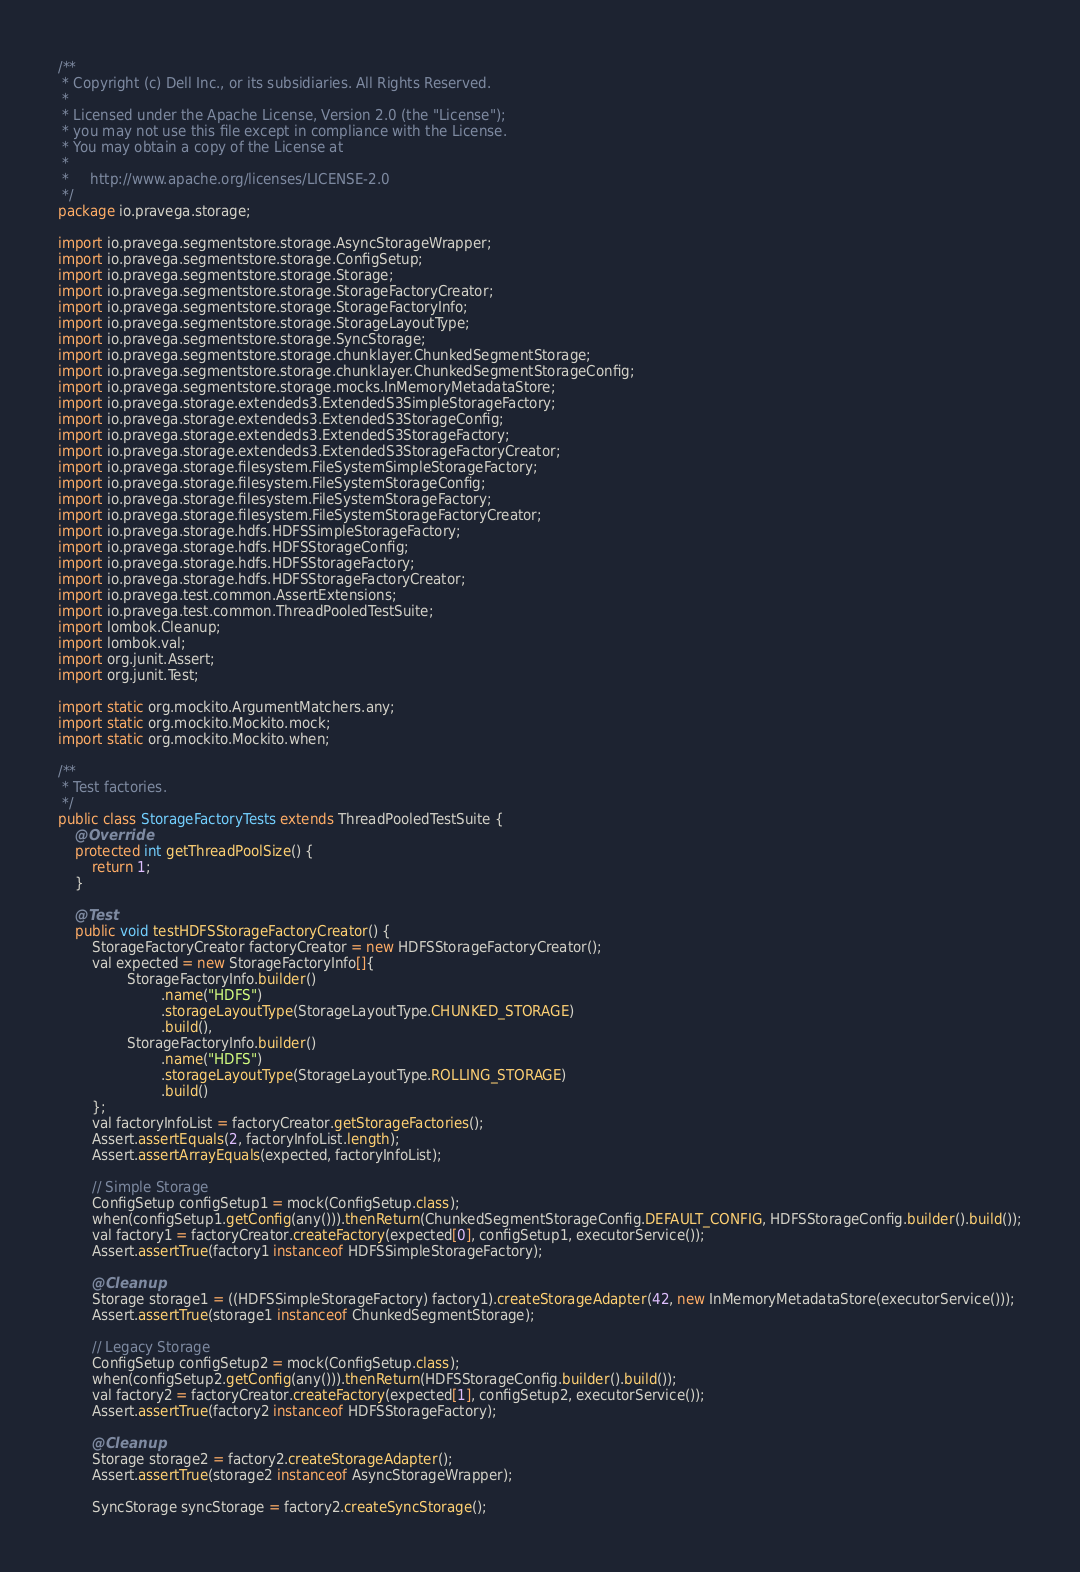Convert code to text. <code><loc_0><loc_0><loc_500><loc_500><_Java_>/**
 * Copyright (c) Dell Inc., or its subsidiaries. All Rights Reserved.
 *
 * Licensed under the Apache License, Version 2.0 (the "License");
 * you may not use this file except in compliance with the License.
 * You may obtain a copy of the License at
 *
 *     http://www.apache.org/licenses/LICENSE-2.0
 */
package io.pravega.storage;

import io.pravega.segmentstore.storage.AsyncStorageWrapper;
import io.pravega.segmentstore.storage.ConfigSetup;
import io.pravega.segmentstore.storage.Storage;
import io.pravega.segmentstore.storage.StorageFactoryCreator;
import io.pravega.segmentstore.storage.StorageFactoryInfo;
import io.pravega.segmentstore.storage.StorageLayoutType;
import io.pravega.segmentstore.storage.SyncStorage;
import io.pravega.segmentstore.storage.chunklayer.ChunkedSegmentStorage;
import io.pravega.segmentstore.storage.chunklayer.ChunkedSegmentStorageConfig;
import io.pravega.segmentstore.storage.mocks.InMemoryMetadataStore;
import io.pravega.storage.extendeds3.ExtendedS3SimpleStorageFactory;
import io.pravega.storage.extendeds3.ExtendedS3StorageConfig;
import io.pravega.storage.extendeds3.ExtendedS3StorageFactory;
import io.pravega.storage.extendeds3.ExtendedS3StorageFactoryCreator;
import io.pravega.storage.filesystem.FileSystemSimpleStorageFactory;
import io.pravega.storage.filesystem.FileSystemStorageConfig;
import io.pravega.storage.filesystem.FileSystemStorageFactory;
import io.pravega.storage.filesystem.FileSystemStorageFactoryCreator;
import io.pravega.storage.hdfs.HDFSSimpleStorageFactory;
import io.pravega.storage.hdfs.HDFSStorageConfig;
import io.pravega.storage.hdfs.HDFSStorageFactory;
import io.pravega.storage.hdfs.HDFSStorageFactoryCreator;
import io.pravega.test.common.AssertExtensions;
import io.pravega.test.common.ThreadPooledTestSuite;
import lombok.Cleanup;
import lombok.val;
import org.junit.Assert;
import org.junit.Test;

import static org.mockito.ArgumentMatchers.any;
import static org.mockito.Mockito.mock;
import static org.mockito.Mockito.when;

/**
 * Test factories.
 */
public class StorageFactoryTests extends ThreadPooledTestSuite {
    @Override
    protected int getThreadPoolSize() {
        return 1;
    }

    @Test
    public void testHDFSStorageFactoryCreator() {
        StorageFactoryCreator factoryCreator = new HDFSStorageFactoryCreator();
        val expected = new StorageFactoryInfo[]{
                StorageFactoryInfo.builder()
                        .name("HDFS")
                        .storageLayoutType(StorageLayoutType.CHUNKED_STORAGE)
                        .build(),
                StorageFactoryInfo.builder()
                        .name("HDFS")
                        .storageLayoutType(StorageLayoutType.ROLLING_STORAGE)
                        .build()
        };
        val factoryInfoList = factoryCreator.getStorageFactories();
        Assert.assertEquals(2, factoryInfoList.length);
        Assert.assertArrayEquals(expected, factoryInfoList);

        // Simple Storage
        ConfigSetup configSetup1 = mock(ConfigSetup.class);
        when(configSetup1.getConfig(any())).thenReturn(ChunkedSegmentStorageConfig.DEFAULT_CONFIG, HDFSStorageConfig.builder().build());
        val factory1 = factoryCreator.createFactory(expected[0], configSetup1, executorService());
        Assert.assertTrue(factory1 instanceof HDFSSimpleStorageFactory);

        @Cleanup
        Storage storage1 = ((HDFSSimpleStorageFactory) factory1).createStorageAdapter(42, new InMemoryMetadataStore(executorService()));
        Assert.assertTrue(storage1 instanceof ChunkedSegmentStorage);

        // Legacy Storage
        ConfigSetup configSetup2 = mock(ConfigSetup.class);
        when(configSetup2.getConfig(any())).thenReturn(HDFSStorageConfig.builder().build());
        val factory2 = factoryCreator.createFactory(expected[1], configSetup2, executorService());
        Assert.assertTrue(factory2 instanceof HDFSStorageFactory);

        @Cleanup
        Storage storage2 = factory2.createStorageAdapter();
        Assert.assertTrue(storage2 instanceof AsyncStorageWrapper);

        SyncStorage syncStorage = factory2.createSyncStorage();</code> 